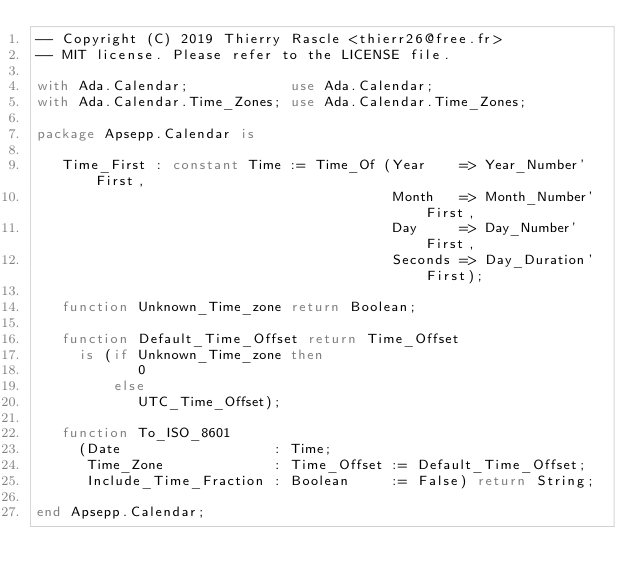Convert code to text. <code><loc_0><loc_0><loc_500><loc_500><_Ada_>-- Copyright (C) 2019 Thierry Rascle <thierr26@free.fr>
-- MIT license. Please refer to the LICENSE file.

with Ada.Calendar;            use Ada.Calendar;
with Ada.Calendar.Time_Zones; use Ada.Calendar.Time_Zones;

package Apsepp.Calendar is

   Time_First : constant Time := Time_Of (Year    => Year_Number'First,
                                          Month   => Month_Number'First,
                                          Day     => Day_Number'First,
                                          Seconds => Day_Duration'First);

   function Unknown_Time_zone return Boolean;

   function Default_Time_Offset return Time_Offset
     is (if Unknown_Time_zone then
            0
         else
            UTC_Time_Offset);

   function To_ISO_8601
     (Date                  : Time;
      Time_Zone             : Time_Offset := Default_Time_Offset;
      Include_Time_Fraction : Boolean     := False) return String;

end Apsepp.Calendar;
</code> 